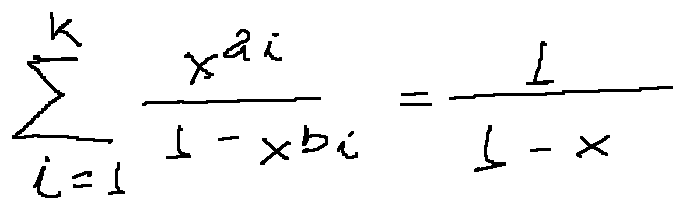Convert formula to latex. <formula><loc_0><loc_0><loc_500><loc_500>\sum \lim i t s _ { i = 1 } ^ { k } \frac { x ^ { a _ { i } } } { 1 - x ^ { b _ { i } } } = \frac { 1 } { 1 - x }</formula> 